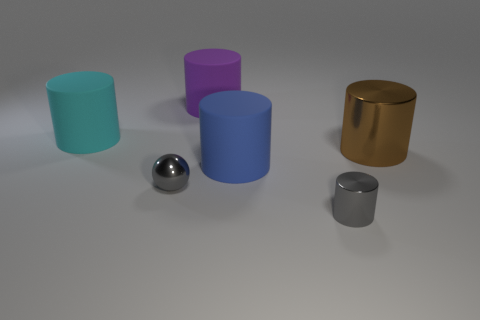Subtract all gray cylinders. How many cylinders are left? 4 Add 1 big cylinders. How many objects exist? 7 Subtract all purple cylinders. How many cylinders are left? 4 Subtract 1 cylinders. How many cylinders are left? 4 Subtract all balls. How many objects are left? 5 Subtract all green spheres. Subtract all green cubes. How many spheres are left? 1 Subtract all cyan cylinders. Subtract all shiny balls. How many objects are left? 4 Add 2 big brown metal cylinders. How many big brown metal cylinders are left? 3 Add 3 big blue matte things. How many big blue matte things exist? 4 Subtract 0 gray cubes. How many objects are left? 6 